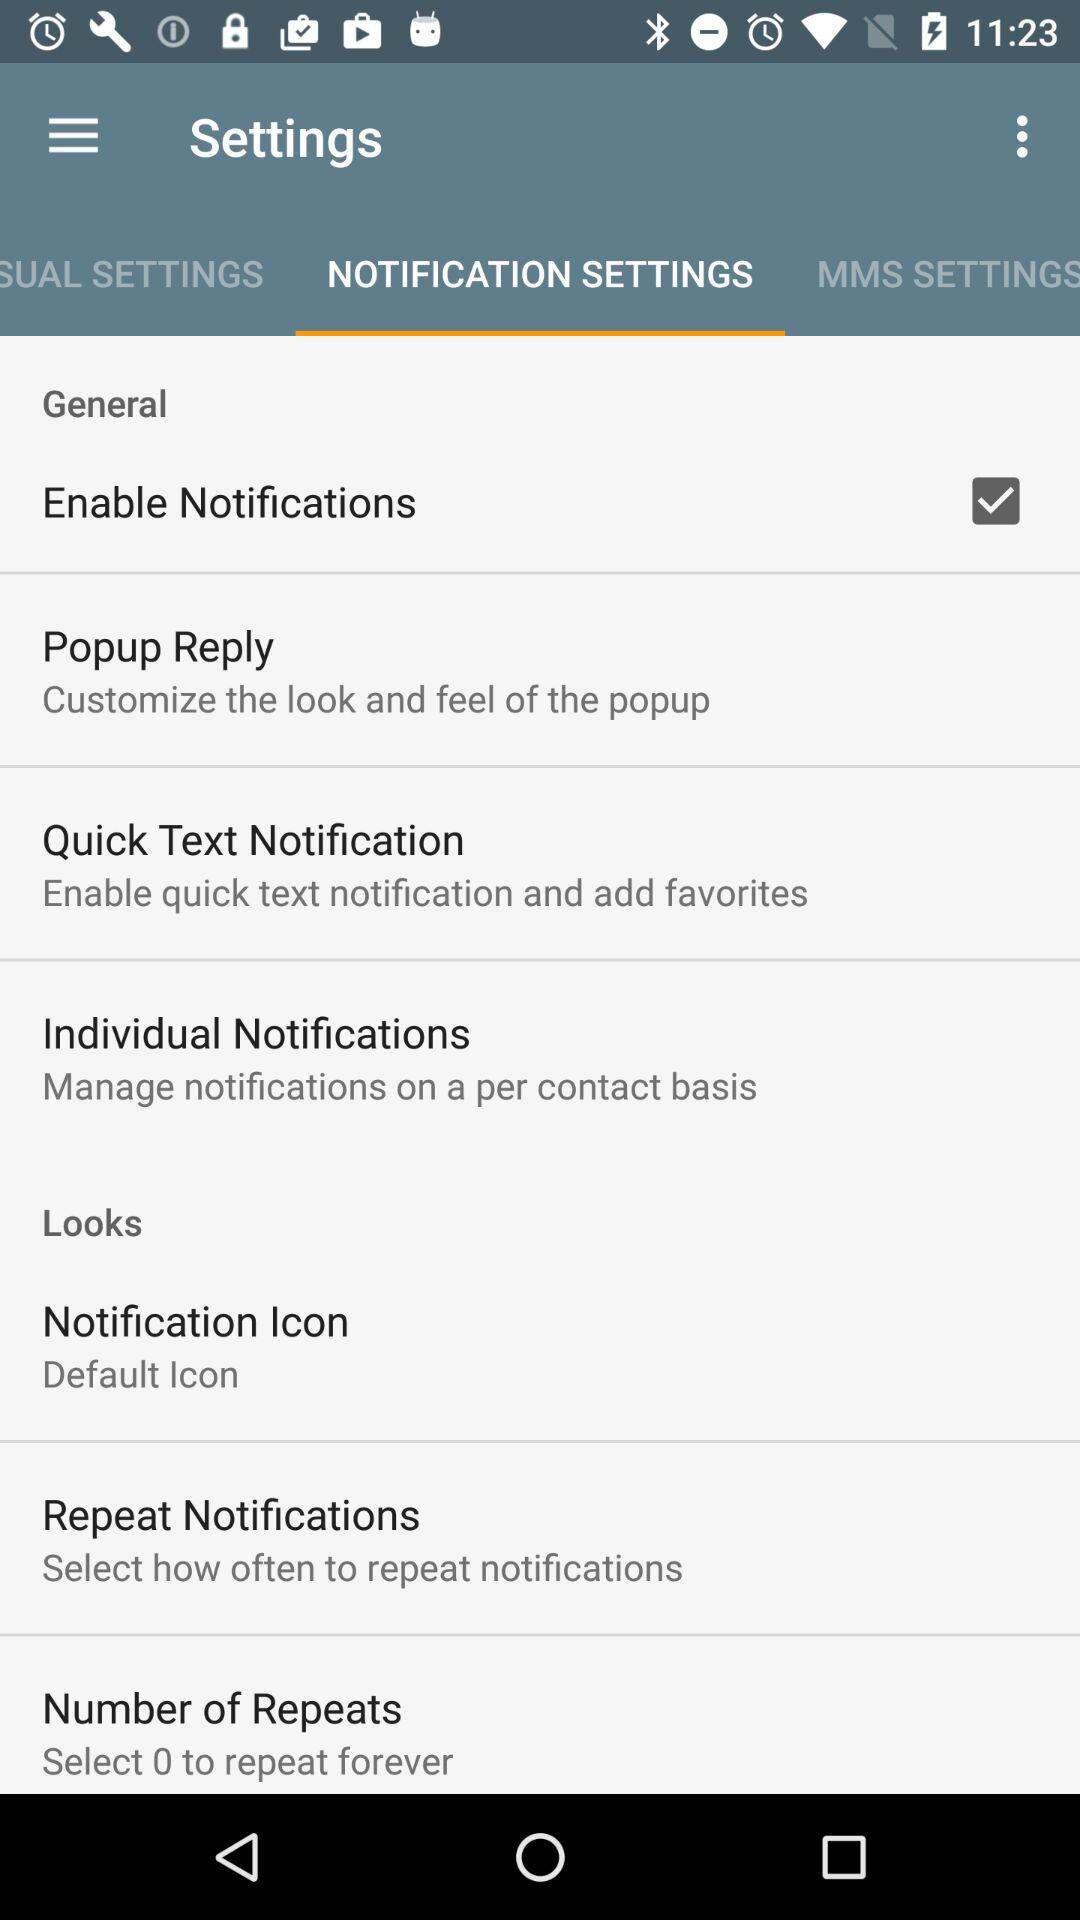What option is selected in "Notification Icon"? The selected option is "Default Icon". 